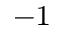<formula> <loc_0><loc_0><loc_500><loc_500>^ { - 1 }</formula> 